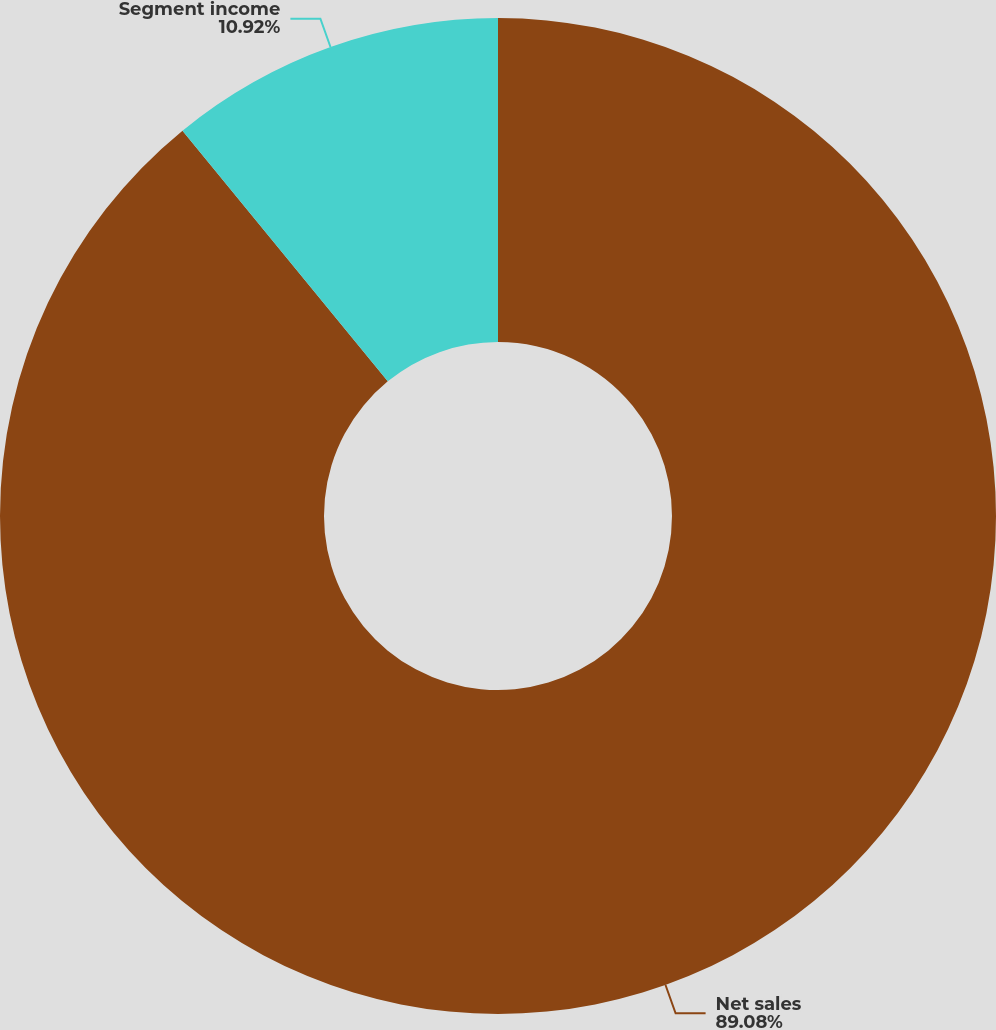Convert chart. <chart><loc_0><loc_0><loc_500><loc_500><pie_chart><fcel>Net sales<fcel>Segment income<nl><fcel>89.08%<fcel>10.92%<nl></chart> 